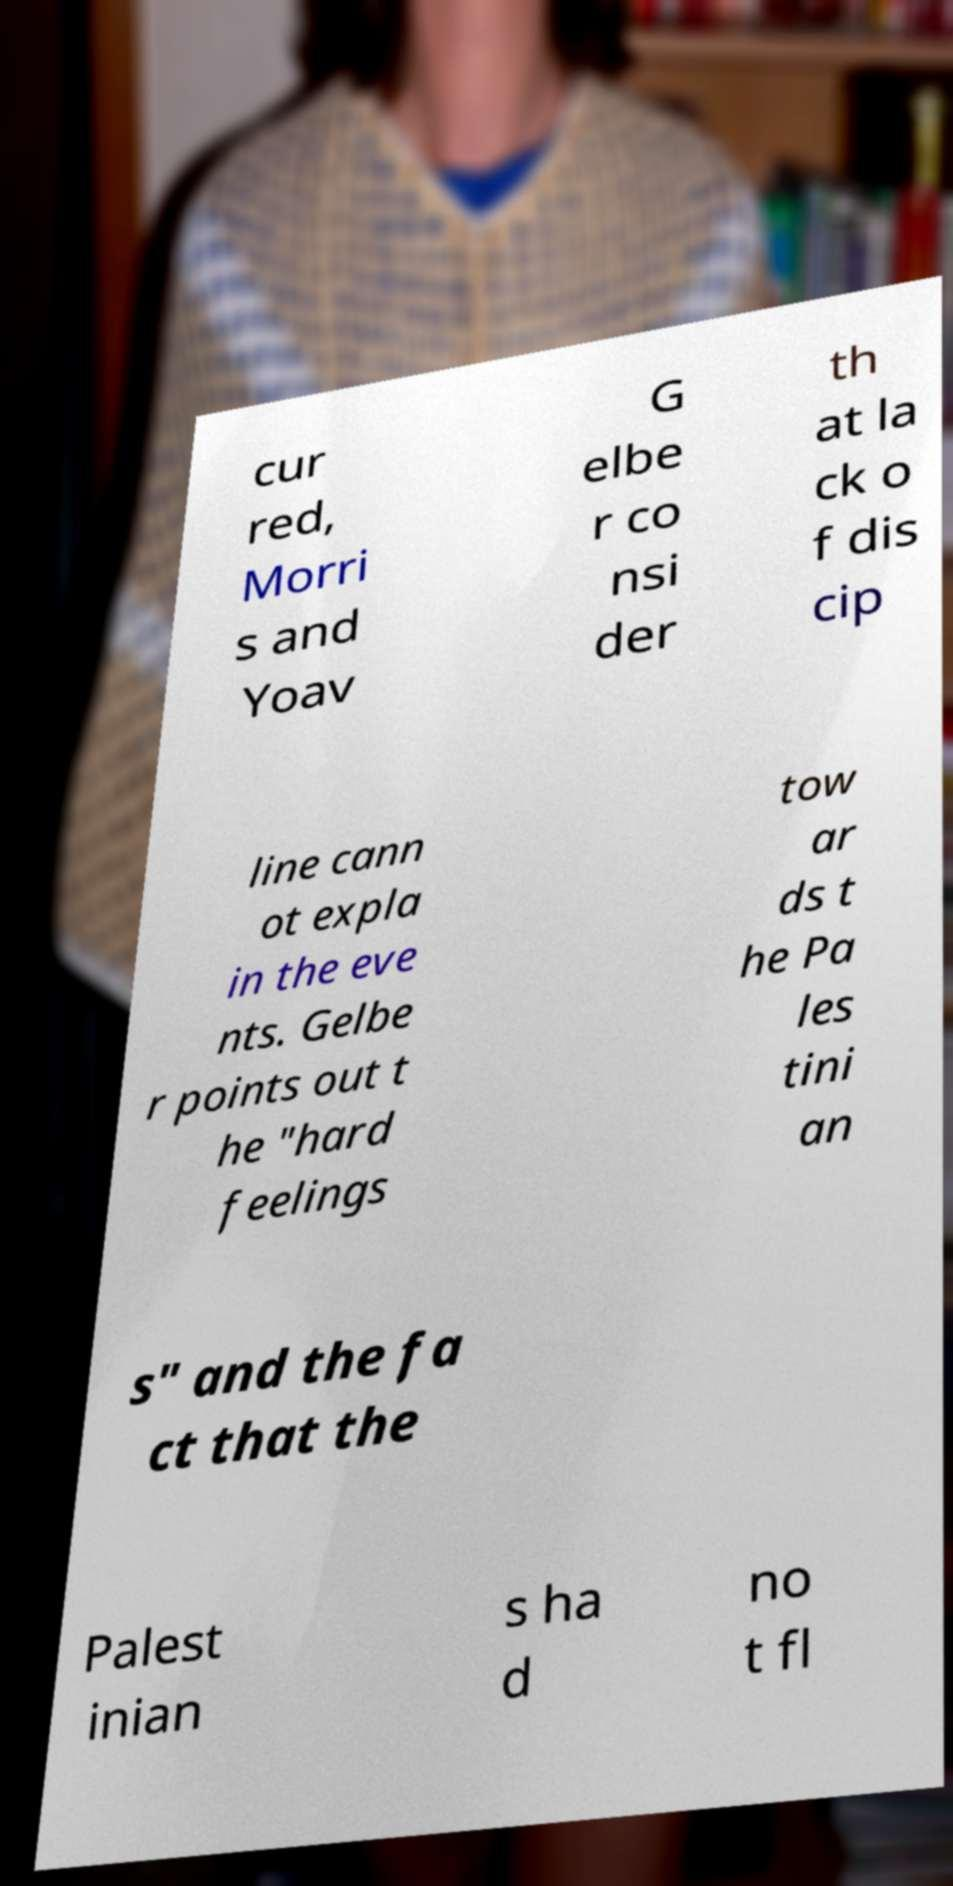Please identify and transcribe the text found in this image. cur red, Morri s and Yoav G elbe r co nsi der th at la ck o f dis cip line cann ot expla in the eve nts. Gelbe r points out t he "hard feelings tow ar ds t he Pa les tini an s" and the fa ct that the Palest inian s ha d no t fl 